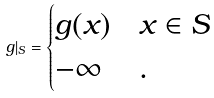<formula> <loc_0><loc_0><loc_500><loc_500>g | _ { S } = \begin{cases} g ( x ) & x \in S \\ - \infty & . \end{cases}</formula> 